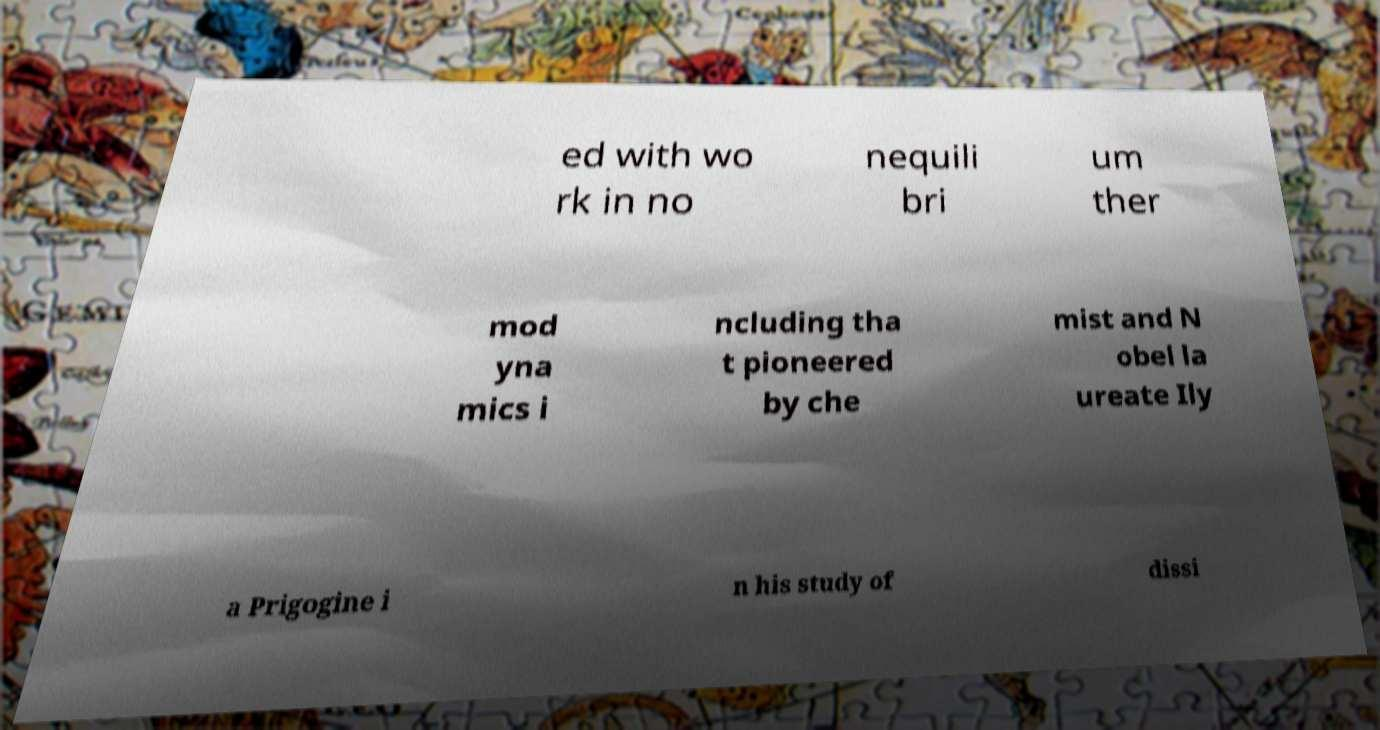Could you extract and type out the text from this image? ed with wo rk in no nequili bri um ther mod yna mics i ncluding tha t pioneered by che mist and N obel la ureate Ily a Prigogine i n his study of dissi 